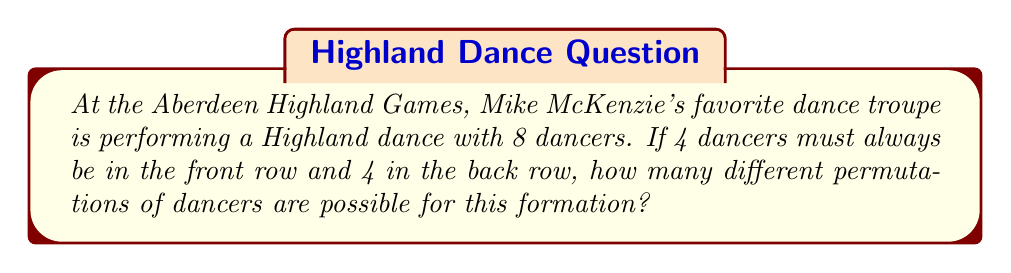Help me with this question. Let's approach this step-by-step:

1) First, we need to consider that we have 8 dancers in total, and they need to be arranged in two rows of 4 each.

2) We can think of this as two separate arrangements:
   a) Arranging 8 dancers into two groups of 4 (front and back)
   b) Arranging the 4 dancers within each row

3) For the first part, we need to choose 4 out of 8 dancers for the front row. This can be done in $\binom{8}{4}$ ways. The remaining 4 will automatically form the back row.

   $\binom{8}{4} = \frac{8!}{4!(8-4)!} = \frac{8!}{4!4!} = 70$

4) Now, for each of these 70 ways of splitting the dancers, we need to arrange the 4 dancers within each row. 

5) For the front row, we can arrange 4 dancers in 4! = 24 ways.
   For the back row, we can also arrange 4 dancers in 4! = 24 ways.

6) By the multiplication principle, for each of the 70 ways of splitting the dancers, we have 24 * 24 = 576 ways of arranging them within their rows.

7) Therefore, the total number of permutations is:

   $70 * 24 * 24 = 70 * 576 = 40,320$

This can also be written as:

$$\binom{8}{4} * 4! * 4! = \frac{8!}{4!4!} * 4! * 4! = 8! = 40,320$$
Answer: 40,320 permutations 